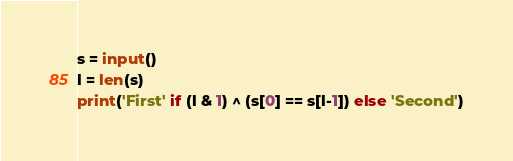<code> <loc_0><loc_0><loc_500><loc_500><_Python_>s = input()
l = len(s)
print('First' if (l & 1) ^ (s[0] == s[l-1]) else 'Second')</code> 